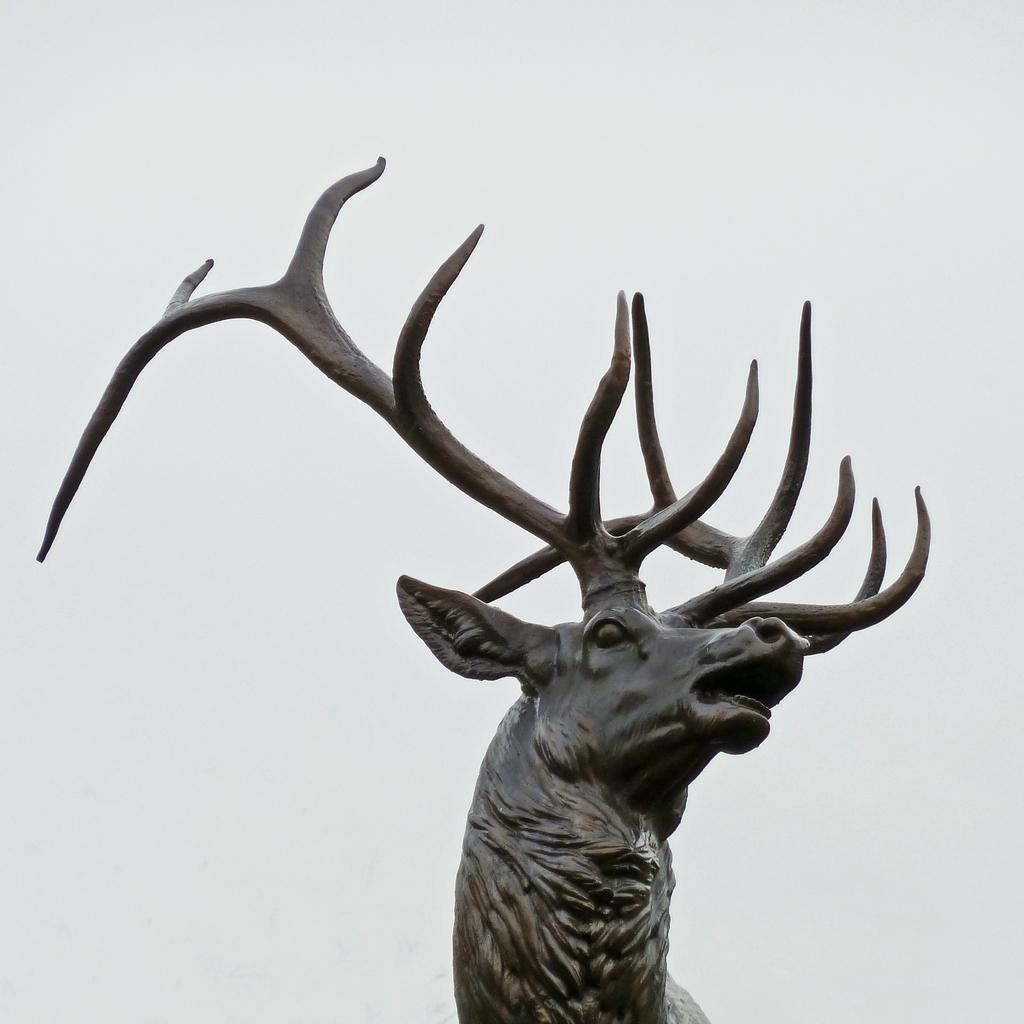What is the main subject of the image? There is a sculpture of an animal in the image. What can be seen in the background of the image? The background of the image is white. Is there a girl holding a light in the cave depicted in the image? There is no cave, girl, or light present in the image; it features a sculpture of an animal with a white background. 